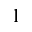<formula> <loc_0><loc_0><loc_500><loc_500>_ { 1 }</formula> 